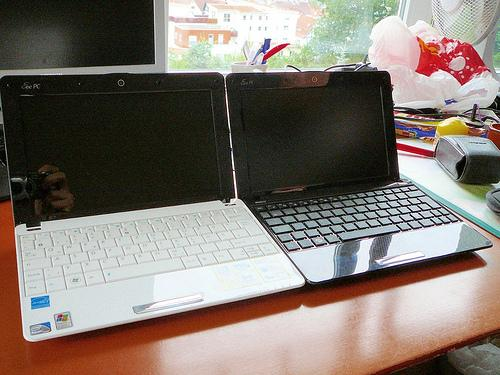Prepare a brief description of the image, specifying the main subject. The image features a black and a white laptop as the principal subject, positioned closely on a desk surrounded by various objects, with a large window in the background. Describe the main objects in the image and their colors. A white laptop and a black laptop are present on a brown table, alongside a white and red shopping bag, a white fan, and a glass window showcasing outdoor scenery. Write a concise description of the most important components in the image. Two contrasting laptops, a black one and a white one, are the centerpieces of this image featuring a wooden desk, a window view, and miscellaneous items. In no more than 30 tokens, convey the main content of the image. The scene displays two laptops, white and black, on a wood desk, accompanied by a fan, a bag, and a window with views of buildings and plants. Briefly describe the main elements in the image and the background. The picture captures two laptops, one white and one black, resting on a wooden desk, with a significant window in the background revealing buildings and plants. Explain the main focus of the image, including the arrangement of objects. The image primarily showcases two laptops, white and black, placed closely beside each other on a wooden desk, with several other items scattered around, including a shopping bag and a fan. In a few words, describe the main objects in the image and their interaction. A white and a black laptop sit side by side on a brown table, accompanied by a fan, a shopping bag, and a window revealing an outdoor scene. Summarize the key items in the image and any notable features. The image highlights a pair of laptops, one in white and the other in black, positioned on a desk with various objects nearby, and a backdrop featuring a large window. State the primary elements in the image and the environment they are in. Two laptops, differing in color, occupy the focus of the image as they are placed on a wooden desk, with additional items scattered around and a window showing the outdoors. Provide a brief overview of the image contents. Two laptops, one black and one white, sit on a wooden desk with a shopping bag and a fan nearby, and a large window with a view of buildings and plants in the background. 